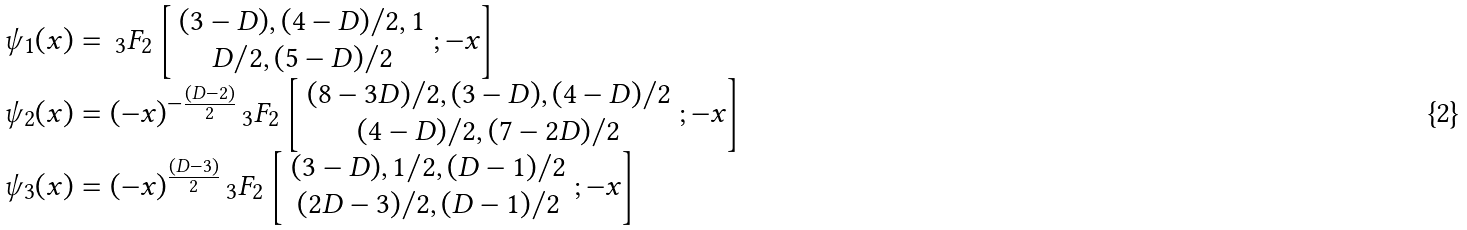Convert formula to latex. <formula><loc_0><loc_0><loc_500><loc_500>\begin{array} { l } \psi _ { 1 } ( x ) = \, _ { 3 } F _ { 2 } \left [ \begin{array} { c } ( 3 - D ) , ( 4 - D ) / 2 , 1 \\ D / 2 , ( 5 - D ) / 2 \end{array} ; - x \right ] \\ \psi _ { 2 } ( x ) = ( - x ) ^ { - \frac { ( D - 2 ) } { 2 } } \, _ { 3 } F _ { 2 } \left [ \begin{array} { c } ( 8 - 3 D ) / 2 , ( 3 - D ) , ( 4 - D ) / 2 \\ ( 4 - D ) / 2 , ( 7 - 2 D ) / 2 \end{array} ; - x \right ] \\ \psi _ { 3 } ( x ) = ( - x ) ^ { \frac { ( D - 3 ) } { 2 } } \, _ { 3 } F _ { 2 } \left [ \begin{array} { c } ( 3 - D ) , 1 / 2 , ( D - 1 ) / 2 \\ ( 2 D - 3 ) / 2 , ( D - 1 ) / 2 \end{array} ; - x \right ] \end{array}</formula> 